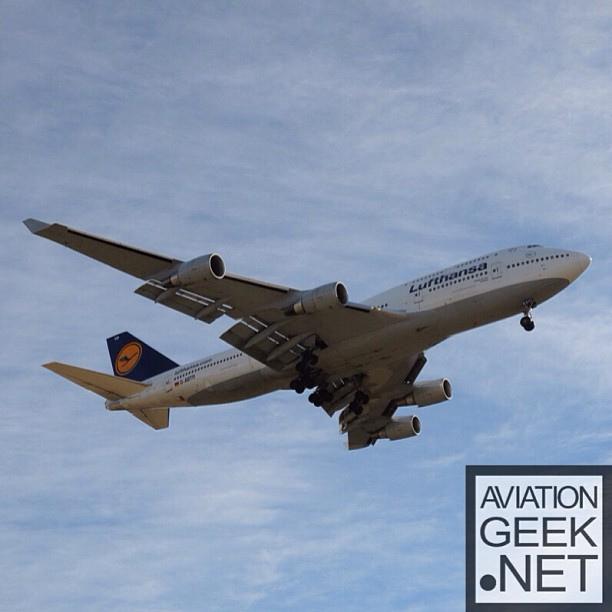What is flying?
Quick response, please. Plane. How many engines are on this vehicle?
Short answer required. 4. The airplane is facing left or right in this picture?
Short answer required. Right. Is the landing gear up or down?
Be succinct. Up. Is it cloudy?
Keep it brief. Yes. 